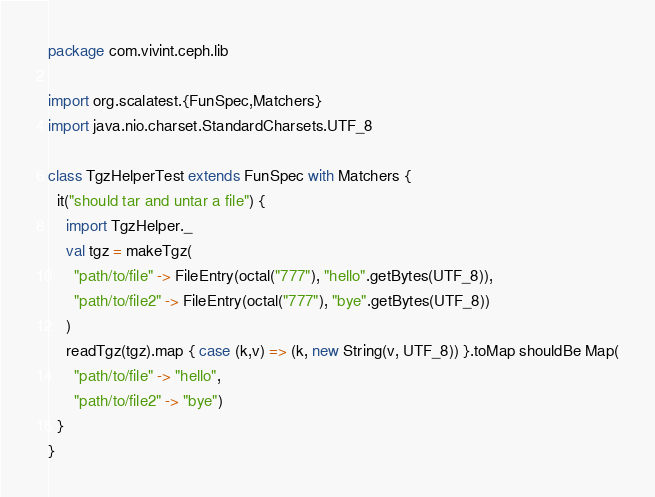<code> <loc_0><loc_0><loc_500><loc_500><_Scala_>package com.vivint.ceph.lib

import org.scalatest.{FunSpec,Matchers}
import java.nio.charset.StandardCharsets.UTF_8

class TgzHelperTest extends FunSpec with Matchers {
  it("should tar and untar a file") {
    import TgzHelper._
    val tgz = makeTgz(
      "path/to/file" -> FileEntry(octal("777"), "hello".getBytes(UTF_8)),
      "path/to/file2" -> FileEntry(octal("777"), "bye".getBytes(UTF_8))
    )
    readTgz(tgz).map { case (k,v) => (k, new String(v, UTF_8)) }.toMap shouldBe Map(
      "path/to/file" -> "hello",
      "path/to/file2" -> "bye")
  }
}
</code> 